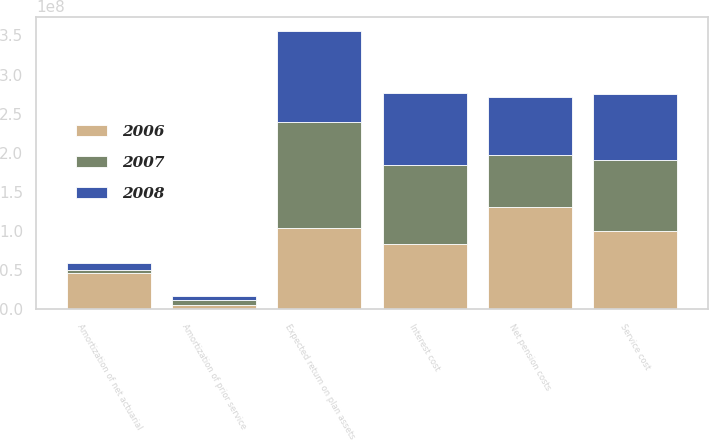Convert chart. <chart><loc_0><loc_0><loc_500><loc_500><stacked_bar_chart><ecel><fcel>Service cost<fcel>Interest cost<fcel>Expected return on plan assets<fcel>Amortization of prior service<fcel>Amortization of net actuarial<fcel>Net pension costs<nl><fcel>2007<fcel>9.057e+07<fcel>1.01218e+08<fcel>1.35345e+08<fcel>5.985e+06<fcel>3.409e+06<fcel>6.5837e+07<nl><fcel>2008<fcel>8.4654e+07<fcel>9.1311e+07<fcel>1.16744e+08<fcel>5.684e+06<fcel>9.686e+06<fcel>7.4591e+07<nl><fcel>2006<fcel>1.00028e+08<fcel>8.36e+07<fcel>1.04174e+08<fcel>4.934e+06<fcel>4.6204e+07<fcel>1.30592e+08<nl></chart> 